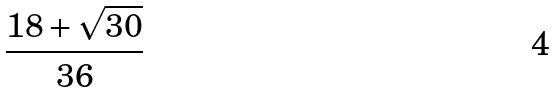<formula> <loc_0><loc_0><loc_500><loc_500>\frac { 1 8 + \sqrt { 3 0 } } { 3 6 }</formula> 